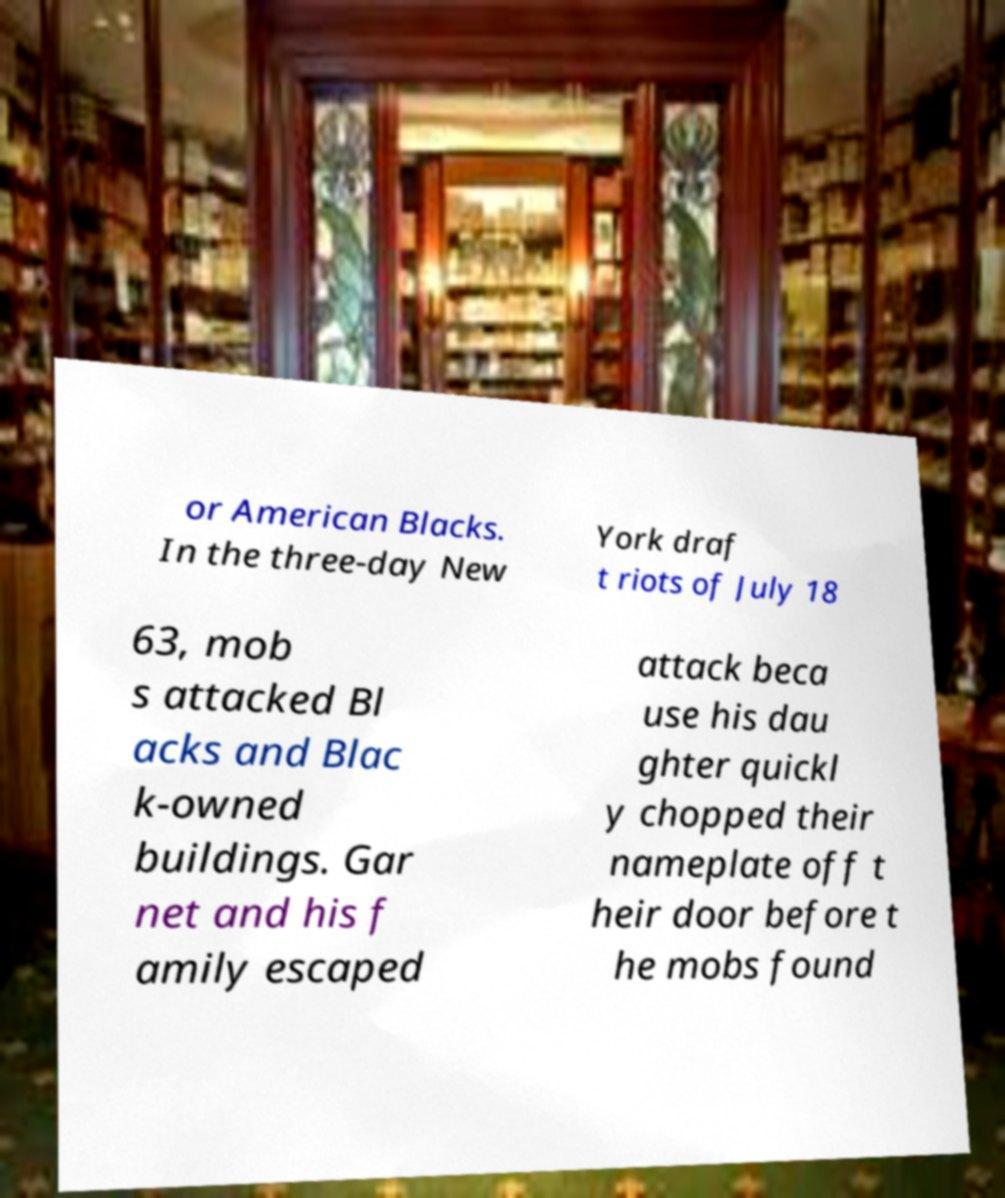Can you read and provide the text displayed in the image?This photo seems to have some interesting text. Can you extract and type it out for me? or American Blacks. In the three-day New York draf t riots of July 18 63, mob s attacked Bl acks and Blac k-owned buildings. Gar net and his f amily escaped attack beca use his dau ghter quickl y chopped their nameplate off t heir door before t he mobs found 